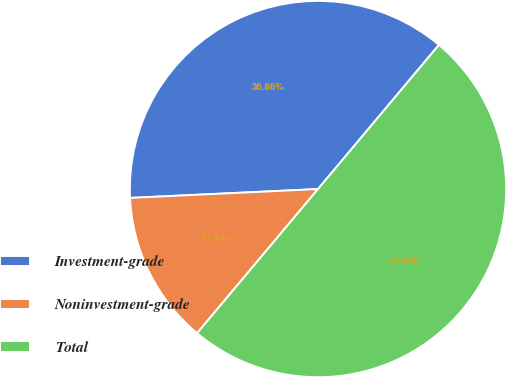<chart> <loc_0><loc_0><loc_500><loc_500><pie_chart><fcel>Investment-grade<fcel>Noninvestment-grade<fcel>Total<nl><fcel>36.86%<fcel>13.14%<fcel>50.0%<nl></chart> 